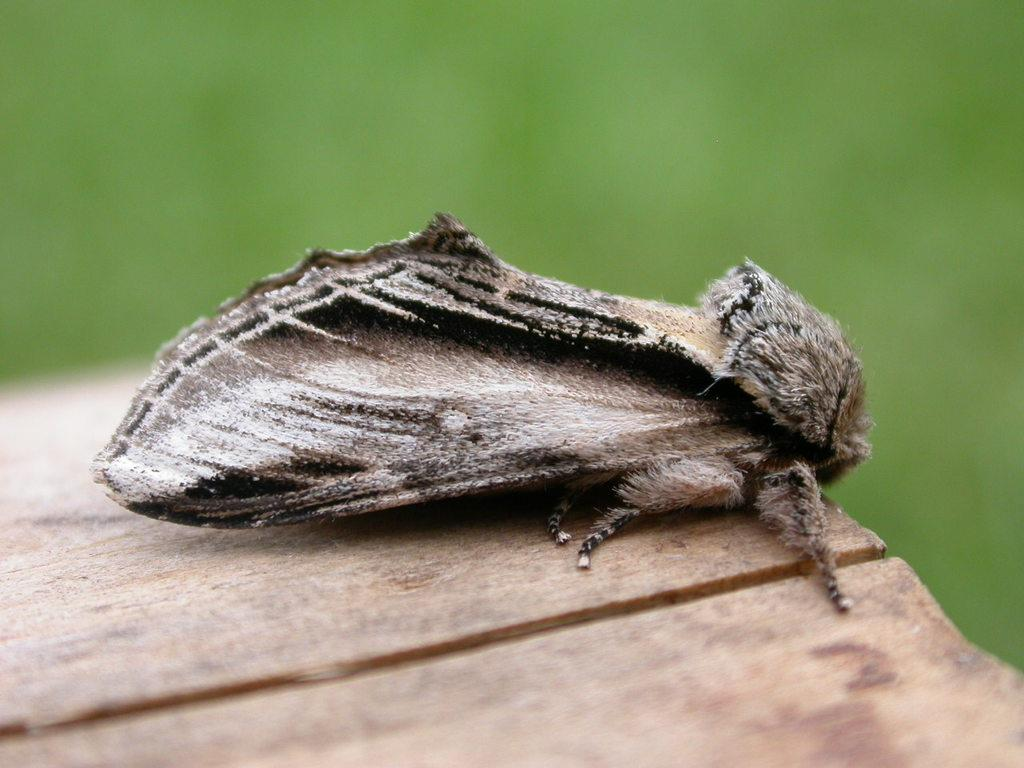What is present on the table in the image? There is an insect on a table in the image. What can be seen in the background of the image? The background of the image is green. What does the insect need to do after it crushes the afterthought? There is no afterthought or any indication of the insect crushing anything in the image. 